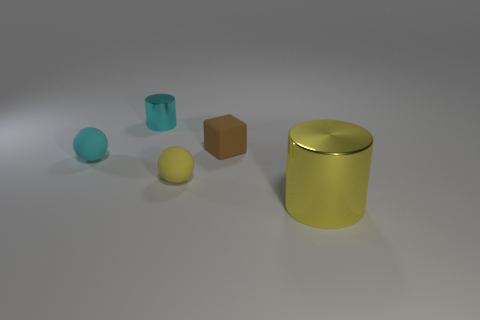Are there any small spheres?
Your answer should be very brief. Yes. Is the number of matte cubes on the left side of the brown rubber thing greater than the number of cyan cylinders to the left of the tiny metallic thing?
Offer a terse response. No. There is a cylinder that is to the left of the cylinder in front of the tiny brown matte block; what color is it?
Your answer should be very brief. Cyan. Are there any metallic cylinders that have the same color as the big shiny thing?
Your answer should be very brief. No. There is a metal cylinder to the right of the cylinder that is behind the yellow object that is to the right of the tiny yellow matte thing; how big is it?
Provide a short and direct response. Large. There is a small metal thing; what shape is it?
Your answer should be compact. Cylinder. What size is the rubber object that is the same color as the large cylinder?
Provide a short and direct response. Small. There is a shiny cylinder to the left of the tiny brown matte object; how many tiny yellow balls are left of it?
Your answer should be very brief. 0. How many other objects are the same material as the tiny yellow sphere?
Your answer should be compact. 2. Does the cyan thing that is behind the small brown rubber block have the same material as the cylinder to the right of the tiny brown matte object?
Keep it short and to the point. Yes. 